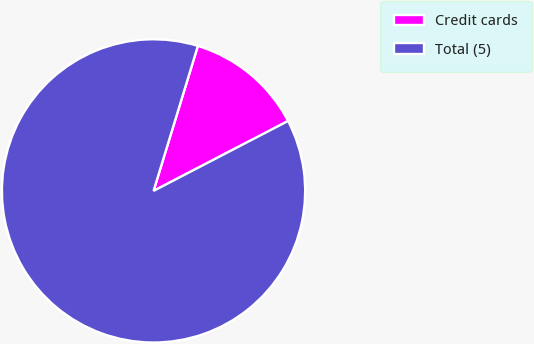<chart> <loc_0><loc_0><loc_500><loc_500><pie_chart><fcel>Credit cards<fcel>Total (5)<nl><fcel>12.65%<fcel>87.35%<nl></chart> 